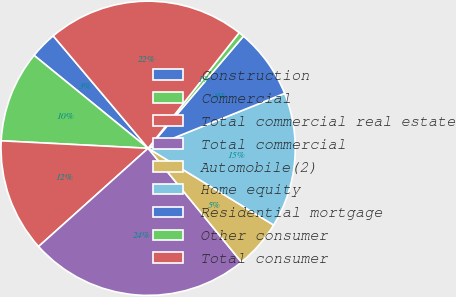Convert chart. <chart><loc_0><loc_0><loc_500><loc_500><pie_chart><fcel>Construction<fcel>Commercial<fcel>Total commercial real estate<fcel>Total commercial<fcel>Automobile(2)<fcel>Home equity<fcel>Residential mortgage<fcel>Other consumer<fcel>Total consumer<nl><fcel>2.96%<fcel>10.07%<fcel>12.44%<fcel>24.3%<fcel>5.33%<fcel>14.82%<fcel>7.7%<fcel>0.59%<fcel>21.78%<nl></chart> 